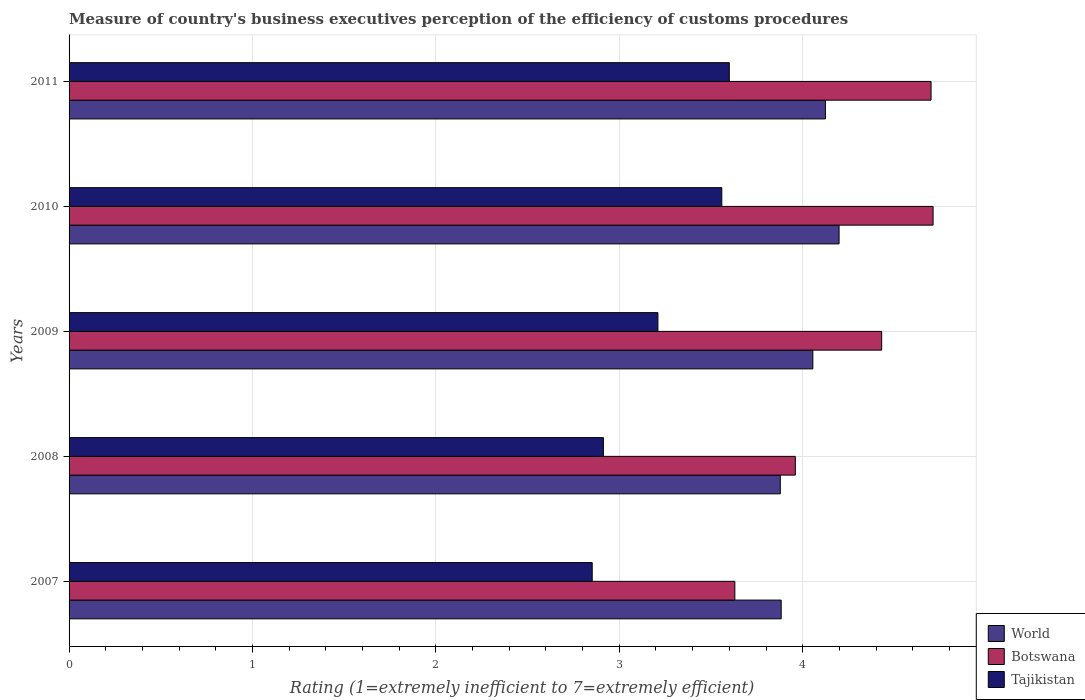How many groups of bars are there?
Provide a succinct answer. 5. Are the number of bars per tick equal to the number of legend labels?
Offer a terse response. Yes. Are the number of bars on each tick of the Y-axis equal?
Provide a succinct answer. Yes. How many bars are there on the 2nd tick from the top?
Provide a succinct answer. 3. What is the rating of the efficiency of customs procedure in Botswana in 2008?
Your answer should be very brief. 3.96. Across all years, what is the maximum rating of the efficiency of customs procedure in Botswana?
Offer a terse response. 4.71. Across all years, what is the minimum rating of the efficiency of customs procedure in Botswana?
Make the answer very short. 3.63. In which year was the rating of the efficiency of customs procedure in Tajikistan maximum?
Give a very brief answer. 2011. In which year was the rating of the efficiency of customs procedure in Tajikistan minimum?
Offer a terse response. 2007. What is the total rating of the efficiency of customs procedure in Botswana in the graph?
Provide a succinct answer. 21.43. What is the difference between the rating of the efficiency of customs procedure in Tajikistan in 2007 and that in 2011?
Offer a very short reply. -0.75. What is the difference between the rating of the efficiency of customs procedure in Tajikistan in 2010 and the rating of the efficiency of customs procedure in Botswana in 2007?
Your response must be concise. -0.07. What is the average rating of the efficiency of customs procedure in Tajikistan per year?
Keep it short and to the point. 3.23. In the year 2007, what is the difference between the rating of the efficiency of customs procedure in Tajikistan and rating of the efficiency of customs procedure in World?
Provide a short and direct response. -1.03. In how many years, is the rating of the efficiency of customs procedure in World greater than 3.6 ?
Provide a short and direct response. 5. What is the ratio of the rating of the efficiency of customs procedure in Botswana in 2007 to that in 2011?
Ensure brevity in your answer.  0.77. Is the rating of the efficiency of customs procedure in World in 2009 less than that in 2010?
Your response must be concise. Yes. Is the difference between the rating of the efficiency of customs procedure in Tajikistan in 2007 and 2010 greater than the difference between the rating of the efficiency of customs procedure in World in 2007 and 2010?
Your response must be concise. No. What is the difference between the highest and the second highest rating of the efficiency of customs procedure in World?
Ensure brevity in your answer.  0.07. What is the difference between the highest and the lowest rating of the efficiency of customs procedure in Botswana?
Make the answer very short. 1.08. In how many years, is the rating of the efficiency of customs procedure in Botswana greater than the average rating of the efficiency of customs procedure in Botswana taken over all years?
Offer a very short reply. 3. Is the sum of the rating of the efficiency of customs procedure in Botswana in 2007 and 2008 greater than the maximum rating of the efficiency of customs procedure in World across all years?
Ensure brevity in your answer.  Yes. What does the 1st bar from the top in 2007 represents?
Provide a short and direct response. Tajikistan. What does the 2nd bar from the bottom in 2007 represents?
Provide a succinct answer. Botswana. Is it the case that in every year, the sum of the rating of the efficiency of customs procedure in Botswana and rating of the efficiency of customs procedure in World is greater than the rating of the efficiency of customs procedure in Tajikistan?
Provide a short and direct response. Yes. How many years are there in the graph?
Your response must be concise. 5. Are the values on the major ticks of X-axis written in scientific E-notation?
Keep it short and to the point. No. Where does the legend appear in the graph?
Your answer should be very brief. Bottom right. How many legend labels are there?
Provide a short and direct response. 3. What is the title of the graph?
Ensure brevity in your answer.  Measure of country's business executives perception of the efficiency of customs procedures. Does "Senegal" appear as one of the legend labels in the graph?
Give a very brief answer. No. What is the label or title of the X-axis?
Keep it short and to the point. Rating (1=extremely inefficient to 7=extremely efficient). What is the label or title of the Y-axis?
Keep it short and to the point. Years. What is the Rating (1=extremely inefficient to 7=extremely efficient) of World in 2007?
Your answer should be compact. 3.88. What is the Rating (1=extremely inefficient to 7=extremely efficient) in Botswana in 2007?
Offer a very short reply. 3.63. What is the Rating (1=extremely inefficient to 7=extremely efficient) of Tajikistan in 2007?
Your response must be concise. 2.85. What is the Rating (1=extremely inefficient to 7=extremely efficient) of World in 2008?
Provide a succinct answer. 3.88. What is the Rating (1=extremely inefficient to 7=extremely efficient) in Botswana in 2008?
Make the answer very short. 3.96. What is the Rating (1=extremely inefficient to 7=extremely efficient) of Tajikistan in 2008?
Offer a terse response. 2.91. What is the Rating (1=extremely inefficient to 7=extremely efficient) of World in 2009?
Offer a very short reply. 4.06. What is the Rating (1=extremely inefficient to 7=extremely efficient) in Botswana in 2009?
Offer a terse response. 4.43. What is the Rating (1=extremely inefficient to 7=extremely efficient) of Tajikistan in 2009?
Make the answer very short. 3.21. What is the Rating (1=extremely inefficient to 7=extremely efficient) of World in 2010?
Provide a short and direct response. 4.2. What is the Rating (1=extremely inefficient to 7=extremely efficient) in Botswana in 2010?
Offer a very short reply. 4.71. What is the Rating (1=extremely inefficient to 7=extremely efficient) of Tajikistan in 2010?
Your answer should be very brief. 3.56. What is the Rating (1=extremely inefficient to 7=extremely efficient) of World in 2011?
Ensure brevity in your answer.  4.12. What is the Rating (1=extremely inefficient to 7=extremely efficient) of Botswana in 2011?
Ensure brevity in your answer.  4.7. What is the Rating (1=extremely inefficient to 7=extremely efficient) in Tajikistan in 2011?
Make the answer very short. 3.6. Across all years, what is the maximum Rating (1=extremely inefficient to 7=extremely efficient) of World?
Ensure brevity in your answer.  4.2. Across all years, what is the maximum Rating (1=extremely inefficient to 7=extremely efficient) of Botswana?
Offer a terse response. 4.71. Across all years, what is the maximum Rating (1=extremely inefficient to 7=extremely efficient) in Tajikistan?
Offer a very short reply. 3.6. Across all years, what is the minimum Rating (1=extremely inefficient to 7=extremely efficient) of World?
Ensure brevity in your answer.  3.88. Across all years, what is the minimum Rating (1=extremely inefficient to 7=extremely efficient) in Botswana?
Provide a succinct answer. 3.63. Across all years, what is the minimum Rating (1=extremely inefficient to 7=extremely efficient) of Tajikistan?
Keep it short and to the point. 2.85. What is the total Rating (1=extremely inefficient to 7=extremely efficient) in World in the graph?
Keep it short and to the point. 20.14. What is the total Rating (1=extremely inefficient to 7=extremely efficient) in Botswana in the graph?
Offer a terse response. 21.43. What is the total Rating (1=extremely inefficient to 7=extremely efficient) of Tajikistan in the graph?
Keep it short and to the point. 16.14. What is the difference between the Rating (1=extremely inefficient to 7=extremely efficient) in World in 2007 and that in 2008?
Your answer should be compact. 0. What is the difference between the Rating (1=extremely inefficient to 7=extremely efficient) in Botswana in 2007 and that in 2008?
Make the answer very short. -0.33. What is the difference between the Rating (1=extremely inefficient to 7=extremely efficient) of Tajikistan in 2007 and that in 2008?
Provide a short and direct response. -0.06. What is the difference between the Rating (1=extremely inefficient to 7=extremely efficient) in World in 2007 and that in 2009?
Your answer should be compact. -0.17. What is the difference between the Rating (1=extremely inefficient to 7=extremely efficient) of Botswana in 2007 and that in 2009?
Provide a short and direct response. -0.8. What is the difference between the Rating (1=extremely inefficient to 7=extremely efficient) in Tajikistan in 2007 and that in 2009?
Make the answer very short. -0.36. What is the difference between the Rating (1=extremely inefficient to 7=extremely efficient) in World in 2007 and that in 2010?
Offer a terse response. -0.32. What is the difference between the Rating (1=extremely inefficient to 7=extremely efficient) in Botswana in 2007 and that in 2010?
Your answer should be compact. -1.08. What is the difference between the Rating (1=extremely inefficient to 7=extremely efficient) in Tajikistan in 2007 and that in 2010?
Give a very brief answer. -0.71. What is the difference between the Rating (1=extremely inefficient to 7=extremely efficient) in World in 2007 and that in 2011?
Offer a very short reply. -0.24. What is the difference between the Rating (1=extremely inefficient to 7=extremely efficient) in Botswana in 2007 and that in 2011?
Ensure brevity in your answer.  -1.07. What is the difference between the Rating (1=extremely inefficient to 7=extremely efficient) of Tajikistan in 2007 and that in 2011?
Ensure brevity in your answer.  -0.75. What is the difference between the Rating (1=extremely inefficient to 7=extremely efficient) in World in 2008 and that in 2009?
Ensure brevity in your answer.  -0.18. What is the difference between the Rating (1=extremely inefficient to 7=extremely efficient) of Botswana in 2008 and that in 2009?
Ensure brevity in your answer.  -0.47. What is the difference between the Rating (1=extremely inefficient to 7=extremely efficient) in Tajikistan in 2008 and that in 2009?
Ensure brevity in your answer.  -0.3. What is the difference between the Rating (1=extremely inefficient to 7=extremely efficient) of World in 2008 and that in 2010?
Offer a terse response. -0.32. What is the difference between the Rating (1=extremely inefficient to 7=extremely efficient) of Botswana in 2008 and that in 2010?
Provide a succinct answer. -0.75. What is the difference between the Rating (1=extremely inefficient to 7=extremely efficient) in Tajikistan in 2008 and that in 2010?
Keep it short and to the point. -0.65. What is the difference between the Rating (1=extremely inefficient to 7=extremely efficient) of World in 2008 and that in 2011?
Your answer should be very brief. -0.25. What is the difference between the Rating (1=extremely inefficient to 7=extremely efficient) in Botswana in 2008 and that in 2011?
Provide a succinct answer. -0.74. What is the difference between the Rating (1=extremely inefficient to 7=extremely efficient) of Tajikistan in 2008 and that in 2011?
Keep it short and to the point. -0.69. What is the difference between the Rating (1=extremely inefficient to 7=extremely efficient) of World in 2009 and that in 2010?
Your response must be concise. -0.14. What is the difference between the Rating (1=extremely inefficient to 7=extremely efficient) of Botswana in 2009 and that in 2010?
Your response must be concise. -0.28. What is the difference between the Rating (1=extremely inefficient to 7=extremely efficient) in Tajikistan in 2009 and that in 2010?
Provide a succinct answer. -0.35. What is the difference between the Rating (1=extremely inefficient to 7=extremely efficient) in World in 2009 and that in 2011?
Keep it short and to the point. -0.07. What is the difference between the Rating (1=extremely inefficient to 7=extremely efficient) in Botswana in 2009 and that in 2011?
Your response must be concise. -0.27. What is the difference between the Rating (1=extremely inefficient to 7=extremely efficient) of Tajikistan in 2009 and that in 2011?
Provide a succinct answer. -0.39. What is the difference between the Rating (1=extremely inefficient to 7=extremely efficient) in World in 2010 and that in 2011?
Your answer should be very brief. 0.07. What is the difference between the Rating (1=extremely inefficient to 7=extremely efficient) of Botswana in 2010 and that in 2011?
Make the answer very short. 0.01. What is the difference between the Rating (1=extremely inefficient to 7=extremely efficient) in Tajikistan in 2010 and that in 2011?
Provide a short and direct response. -0.04. What is the difference between the Rating (1=extremely inefficient to 7=extremely efficient) of World in 2007 and the Rating (1=extremely inefficient to 7=extremely efficient) of Botswana in 2008?
Your response must be concise. -0.08. What is the difference between the Rating (1=extremely inefficient to 7=extremely efficient) in World in 2007 and the Rating (1=extremely inefficient to 7=extremely efficient) in Tajikistan in 2008?
Provide a succinct answer. 0.97. What is the difference between the Rating (1=extremely inefficient to 7=extremely efficient) of Botswana in 2007 and the Rating (1=extremely inefficient to 7=extremely efficient) of Tajikistan in 2008?
Your response must be concise. 0.72. What is the difference between the Rating (1=extremely inefficient to 7=extremely efficient) of World in 2007 and the Rating (1=extremely inefficient to 7=extremely efficient) of Botswana in 2009?
Offer a terse response. -0.55. What is the difference between the Rating (1=extremely inefficient to 7=extremely efficient) in World in 2007 and the Rating (1=extremely inefficient to 7=extremely efficient) in Tajikistan in 2009?
Your response must be concise. 0.67. What is the difference between the Rating (1=extremely inefficient to 7=extremely efficient) of Botswana in 2007 and the Rating (1=extremely inefficient to 7=extremely efficient) of Tajikistan in 2009?
Offer a terse response. 0.42. What is the difference between the Rating (1=extremely inefficient to 7=extremely efficient) of World in 2007 and the Rating (1=extremely inefficient to 7=extremely efficient) of Botswana in 2010?
Offer a terse response. -0.83. What is the difference between the Rating (1=extremely inefficient to 7=extremely efficient) of World in 2007 and the Rating (1=extremely inefficient to 7=extremely efficient) of Tajikistan in 2010?
Provide a succinct answer. 0.32. What is the difference between the Rating (1=extremely inefficient to 7=extremely efficient) in Botswana in 2007 and the Rating (1=extremely inefficient to 7=extremely efficient) in Tajikistan in 2010?
Provide a succinct answer. 0.07. What is the difference between the Rating (1=extremely inefficient to 7=extremely efficient) of World in 2007 and the Rating (1=extremely inefficient to 7=extremely efficient) of Botswana in 2011?
Offer a very short reply. -0.82. What is the difference between the Rating (1=extremely inefficient to 7=extremely efficient) of World in 2007 and the Rating (1=extremely inefficient to 7=extremely efficient) of Tajikistan in 2011?
Keep it short and to the point. 0.28. What is the difference between the Rating (1=extremely inefficient to 7=extremely efficient) of Botswana in 2007 and the Rating (1=extremely inefficient to 7=extremely efficient) of Tajikistan in 2011?
Ensure brevity in your answer.  0.03. What is the difference between the Rating (1=extremely inefficient to 7=extremely efficient) in World in 2008 and the Rating (1=extremely inefficient to 7=extremely efficient) in Botswana in 2009?
Offer a very short reply. -0.55. What is the difference between the Rating (1=extremely inefficient to 7=extremely efficient) in World in 2008 and the Rating (1=extremely inefficient to 7=extremely efficient) in Tajikistan in 2009?
Provide a succinct answer. 0.67. What is the difference between the Rating (1=extremely inefficient to 7=extremely efficient) of Botswana in 2008 and the Rating (1=extremely inefficient to 7=extremely efficient) of Tajikistan in 2009?
Offer a very short reply. 0.75. What is the difference between the Rating (1=extremely inefficient to 7=extremely efficient) of World in 2008 and the Rating (1=extremely inefficient to 7=extremely efficient) of Botswana in 2010?
Provide a short and direct response. -0.83. What is the difference between the Rating (1=extremely inefficient to 7=extremely efficient) of World in 2008 and the Rating (1=extremely inefficient to 7=extremely efficient) of Tajikistan in 2010?
Ensure brevity in your answer.  0.32. What is the difference between the Rating (1=extremely inefficient to 7=extremely efficient) of Botswana in 2008 and the Rating (1=extremely inefficient to 7=extremely efficient) of Tajikistan in 2010?
Your answer should be very brief. 0.4. What is the difference between the Rating (1=extremely inefficient to 7=extremely efficient) of World in 2008 and the Rating (1=extremely inefficient to 7=extremely efficient) of Botswana in 2011?
Your answer should be very brief. -0.82. What is the difference between the Rating (1=extremely inefficient to 7=extremely efficient) in World in 2008 and the Rating (1=extremely inefficient to 7=extremely efficient) in Tajikistan in 2011?
Ensure brevity in your answer.  0.28. What is the difference between the Rating (1=extremely inefficient to 7=extremely efficient) of Botswana in 2008 and the Rating (1=extremely inefficient to 7=extremely efficient) of Tajikistan in 2011?
Offer a terse response. 0.36. What is the difference between the Rating (1=extremely inefficient to 7=extremely efficient) in World in 2009 and the Rating (1=extremely inefficient to 7=extremely efficient) in Botswana in 2010?
Offer a very short reply. -0.66. What is the difference between the Rating (1=extremely inefficient to 7=extremely efficient) of World in 2009 and the Rating (1=extremely inefficient to 7=extremely efficient) of Tajikistan in 2010?
Your response must be concise. 0.5. What is the difference between the Rating (1=extremely inefficient to 7=extremely efficient) of Botswana in 2009 and the Rating (1=extremely inefficient to 7=extremely efficient) of Tajikistan in 2010?
Provide a short and direct response. 0.87. What is the difference between the Rating (1=extremely inefficient to 7=extremely efficient) in World in 2009 and the Rating (1=extremely inefficient to 7=extremely efficient) in Botswana in 2011?
Make the answer very short. -0.64. What is the difference between the Rating (1=extremely inefficient to 7=extremely efficient) in World in 2009 and the Rating (1=extremely inefficient to 7=extremely efficient) in Tajikistan in 2011?
Give a very brief answer. 0.46. What is the difference between the Rating (1=extremely inefficient to 7=extremely efficient) in Botswana in 2009 and the Rating (1=extremely inefficient to 7=extremely efficient) in Tajikistan in 2011?
Offer a terse response. 0.83. What is the difference between the Rating (1=extremely inefficient to 7=extremely efficient) in World in 2010 and the Rating (1=extremely inefficient to 7=extremely efficient) in Botswana in 2011?
Your answer should be compact. -0.5. What is the difference between the Rating (1=extremely inefficient to 7=extremely efficient) of World in 2010 and the Rating (1=extremely inefficient to 7=extremely efficient) of Tajikistan in 2011?
Provide a succinct answer. 0.6. What is the difference between the Rating (1=extremely inefficient to 7=extremely efficient) of Botswana in 2010 and the Rating (1=extremely inefficient to 7=extremely efficient) of Tajikistan in 2011?
Offer a very short reply. 1.11. What is the average Rating (1=extremely inefficient to 7=extremely efficient) of World per year?
Your answer should be compact. 4.03. What is the average Rating (1=extremely inefficient to 7=extremely efficient) in Botswana per year?
Offer a terse response. 4.29. What is the average Rating (1=extremely inefficient to 7=extremely efficient) of Tajikistan per year?
Provide a short and direct response. 3.23. In the year 2007, what is the difference between the Rating (1=extremely inefficient to 7=extremely efficient) of World and Rating (1=extremely inefficient to 7=extremely efficient) of Botswana?
Give a very brief answer. 0.25. In the year 2007, what is the difference between the Rating (1=extremely inefficient to 7=extremely efficient) in World and Rating (1=extremely inefficient to 7=extremely efficient) in Tajikistan?
Give a very brief answer. 1.03. In the year 2007, what is the difference between the Rating (1=extremely inefficient to 7=extremely efficient) in Botswana and Rating (1=extremely inefficient to 7=extremely efficient) in Tajikistan?
Offer a very short reply. 0.78. In the year 2008, what is the difference between the Rating (1=extremely inefficient to 7=extremely efficient) of World and Rating (1=extremely inefficient to 7=extremely efficient) of Botswana?
Your response must be concise. -0.08. In the year 2008, what is the difference between the Rating (1=extremely inefficient to 7=extremely efficient) of World and Rating (1=extremely inefficient to 7=extremely efficient) of Tajikistan?
Make the answer very short. 0.96. In the year 2008, what is the difference between the Rating (1=extremely inefficient to 7=extremely efficient) of Botswana and Rating (1=extremely inefficient to 7=extremely efficient) of Tajikistan?
Offer a terse response. 1.05. In the year 2009, what is the difference between the Rating (1=extremely inefficient to 7=extremely efficient) in World and Rating (1=extremely inefficient to 7=extremely efficient) in Botswana?
Provide a succinct answer. -0.38. In the year 2009, what is the difference between the Rating (1=extremely inefficient to 7=extremely efficient) of World and Rating (1=extremely inefficient to 7=extremely efficient) of Tajikistan?
Your answer should be compact. 0.84. In the year 2009, what is the difference between the Rating (1=extremely inefficient to 7=extremely efficient) in Botswana and Rating (1=extremely inefficient to 7=extremely efficient) in Tajikistan?
Keep it short and to the point. 1.22. In the year 2010, what is the difference between the Rating (1=extremely inefficient to 7=extremely efficient) of World and Rating (1=extremely inefficient to 7=extremely efficient) of Botswana?
Make the answer very short. -0.51. In the year 2010, what is the difference between the Rating (1=extremely inefficient to 7=extremely efficient) of World and Rating (1=extremely inefficient to 7=extremely efficient) of Tajikistan?
Offer a terse response. 0.64. In the year 2010, what is the difference between the Rating (1=extremely inefficient to 7=extremely efficient) of Botswana and Rating (1=extremely inefficient to 7=extremely efficient) of Tajikistan?
Provide a short and direct response. 1.15. In the year 2011, what is the difference between the Rating (1=extremely inefficient to 7=extremely efficient) of World and Rating (1=extremely inefficient to 7=extremely efficient) of Botswana?
Provide a succinct answer. -0.58. In the year 2011, what is the difference between the Rating (1=extremely inefficient to 7=extremely efficient) of World and Rating (1=extremely inefficient to 7=extremely efficient) of Tajikistan?
Offer a terse response. 0.52. In the year 2011, what is the difference between the Rating (1=extremely inefficient to 7=extremely efficient) in Botswana and Rating (1=extremely inefficient to 7=extremely efficient) in Tajikistan?
Your response must be concise. 1.1. What is the ratio of the Rating (1=extremely inefficient to 7=extremely efficient) in Tajikistan in 2007 to that in 2008?
Ensure brevity in your answer.  0.98. What is the ratio of the Rating (1=extremely inefficient to 7=extremely efficient) of World in 2007 to that in 2009?
Ensure brevity in your answer.  0.96. What is the ratio of the Rating (1=extremely inefficient to 7=extremely efficient) of Botswana in 2007 to that in 2009?
Provide a succinct answer. 0.82. What is the ratio of the Rating (1=extremely inefficient to 7=extremely efficient) of Tajikistan in 2007 to that in 2009?
Your answer should be very brief. 0.89. What is the ratio of the Rating (1=extremely inefficient to 7=extremely efficient) in World in 2007 to that in 2010?
Offer a terse response. 0.92. What is the ratio of the Rating (1=extremely inefficient to 7=extremely efficient) of Botswana in 2007 to that in 2010?
Keep it short and to the point. 0.77. What is the ratio of the Rating (1=extremely inefficient to 7=extremely efficient) of Tajikistan in 2007 to that in 2010?
Keep it short and to the point. 0.8. What is the ratio of the Rating (1=extremely inefficient to 7=extremely efficient) of World in 2007 to that in 2011?
Ensure brevity in your answer.  0.94. What is the ratio of the Rating (1=extremely inefficient to 7=extremely efficient) in Botswana in 2007 to that in 2011?
Your answer should be very brief. 0.77. What is the ratio of the Rating (1=extremely inefficient to 7=extremely efficient) in Tajikistan in 2007 to that in 2011?
Provide a succinct answer. 0.79. What is the ratio of the Rating (1=extremely inefficient to 7=extremely efficient) of World in 2008 to that in 2009?
Provide a short and direct response. 0.96. What is the ratio of the Rating (1=extremely inefficient to 7=extremely efficient) in Botswana in 2008 to that in 2009?
Give a very brief answer. 0.89. What is the ratio of the Rating (1=extremely inefficient to 7=extremely efficient) of Tajikistan in 2008 to that in 2009?
Offer a terse response. 0.91. What is the ratio of the Rating (1=extremely inefficient to 7=extremely efficient) in World in 2008 to that in 2010?
Make the answer very short. 0.92. What is the ratio of the Rating (1=extremely inefficient to 7=extremely efficient) of Botswana in 2008 to that in 2010?
Offer a terse response. 0.84. What is the ratio of the Rating (1=extremely inefficient to 7=extremely efficient) in Tajikistan in 2008 to that in 2010?
Offer a very short reply. 0.82. What is the ratio of the Rating (1=extremely inefficient to 7=extremely efficient) in World in 2008 to that in 2011?
Give a very brief answer. 0.94. What is the ratio of the Rating (1=extremely inefficient to 7=extremely efficient) in Botswana in 2008 to that in 2011?
Your response must be concise. 0.84. What is the ratio of the Rating (1=extremely inefficient to 7=extremely efficient) in Tajikistan in 2008 to that in 2011?
Give a very brief answer. 0.81. What is the ratio of the Rating (1=extremely inefficient to 7=extremely efficient) in World in 2009 to that in 2010?
Ensure brevity in your answer.  0.97. What is the ratio of the Rating (1=extremely inefficient to 7=extremely efficient) of Botswana in 2009 to that in 2010?
Your answer should be very brief. 0.94. What is the ratio of the Rating (1=extremely inefficient to 7=extremely efficient) in Tajikistan in 2009 to that in 2010?
Make the answer very short. 0.9. What is the ratio of the Rating (1=extremely inefficient to 7=extremely efficient) in World in 2009 to that in 2011?
Ensure brevity in your answer.  0.98. What is the ratio of the Rating (1=extremely inefficient to 7=extremely efficient) of Botswana in 2009 to that in 2011?
Provide a short and direct response. 0.94. What is the ratio of the Rating (1=extremely inefficient to 7=extremely efficient) of Tajikistan in 2009 to that in 2011?
Your response must be concise. 0.89. What is the ratio of the Rating (1=extremely inefficient to 7=extremely efficient) in World in 2010 to that in 2011?
Make the answer very short. 1.02. What is the ratio of the Rating (1=extremely inefficient to 7=extremely efficient) in Botswana in 2010 to that in 2011?
Your answer should be compact. 1. What is the difference between the highest and the second highest Rating (1=extremely inefficient to 7=extremely efficient) in World?
Keep it short and to the point. 0.07. What is the difference between the highest and the second highest Rating (1=extremely inefficient to 7=extremely efficient) of Botswana?
Give a very brief answer. 0.01. What is the difference between the highest and the second highest Rating (1=extremely inefficient to 7=extremely efficient) in Tajikistan?
Keep it short and to the point. 0.04. What is the difference between the highest and the lowest Rating (1=extremely inefficient to 7=extremely efficient) of World?
Provide a short and direct response. 0.32. What is the difference between the highest and the lowest Rating (1=extremely inefficient to 7=extremely efficient) of Botswana?
Ensure brevity in your answer.  1.08. What is the difference between the highest and the lowest Rating (1=extremely inefficient to 7=extremely efficient) in Tajikistan?
Your answer should be very brief. 0.75. 